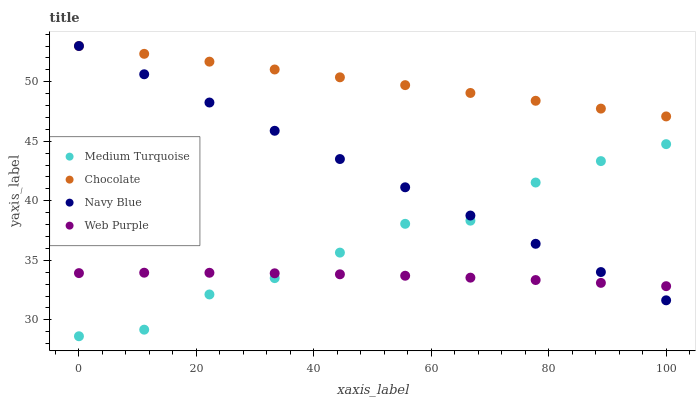Does Web Purple have the minimum area under the curve?
Answer yes or no. Yes. Does Chocolate have the maximum area under the curve?
Answer yes or no. Yes. Does Medium Turquoise have the minimum area under the curve?
Answer yes or no. No. Does Medium Turquoise have the maximum area under the curve?
Answer yes or no. No. Is Navy Blue the smoothest?
Answer yes or no. Yes. Is Medium Turquoise the roughest?
Answer yes or no. Yes. Is Web Purple the smoothest?
Answer yes or no. No. Is Web Purple the roughest?
Answer yes or no. No. Does Medium Turquoise have the lowest value?
Answer yes or no. Yes. Does Web Purple have the lowest value?
Answer yes or no. No. Does Chocolate have the highest value?
Answer yes or no. Yes. Does Medium Turquoise have the highest value?
Answer yes or no. No. Is Medium Turquoise less than Chocolate?
Answer yes or no. Yes. Is Chocolate greater than Web Purple?
Answer yes or no. Yes. Does Web Purple intersect Medium Turquoise?
Answer yes or no. Yes. Is Web Purple less than Medium Turquoise?
Answer yes or no. No. Is Web Purple greater than Medium Turquoise?
Answer yes or no. No. Does Medium Turquoise intersect Chocolate?
Answer yes or no. No. 